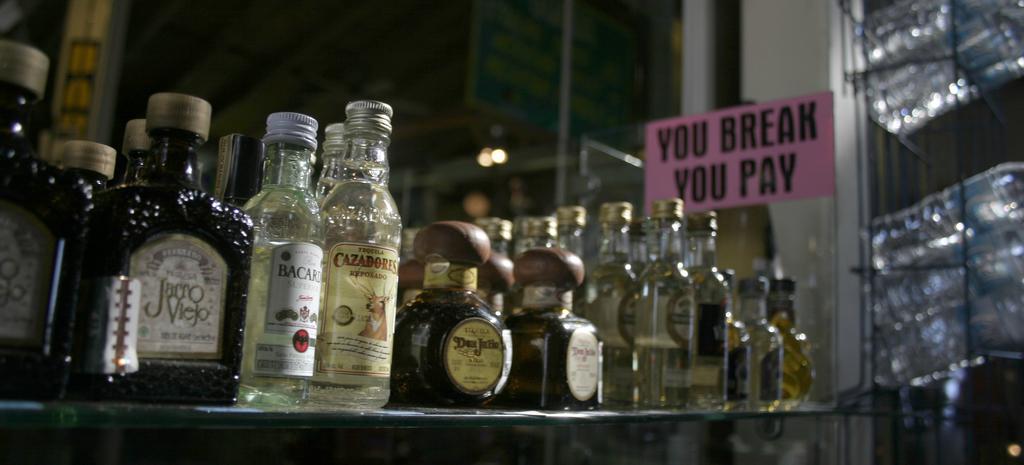What happens if you break something?
Offer a very short reply. You pay. 